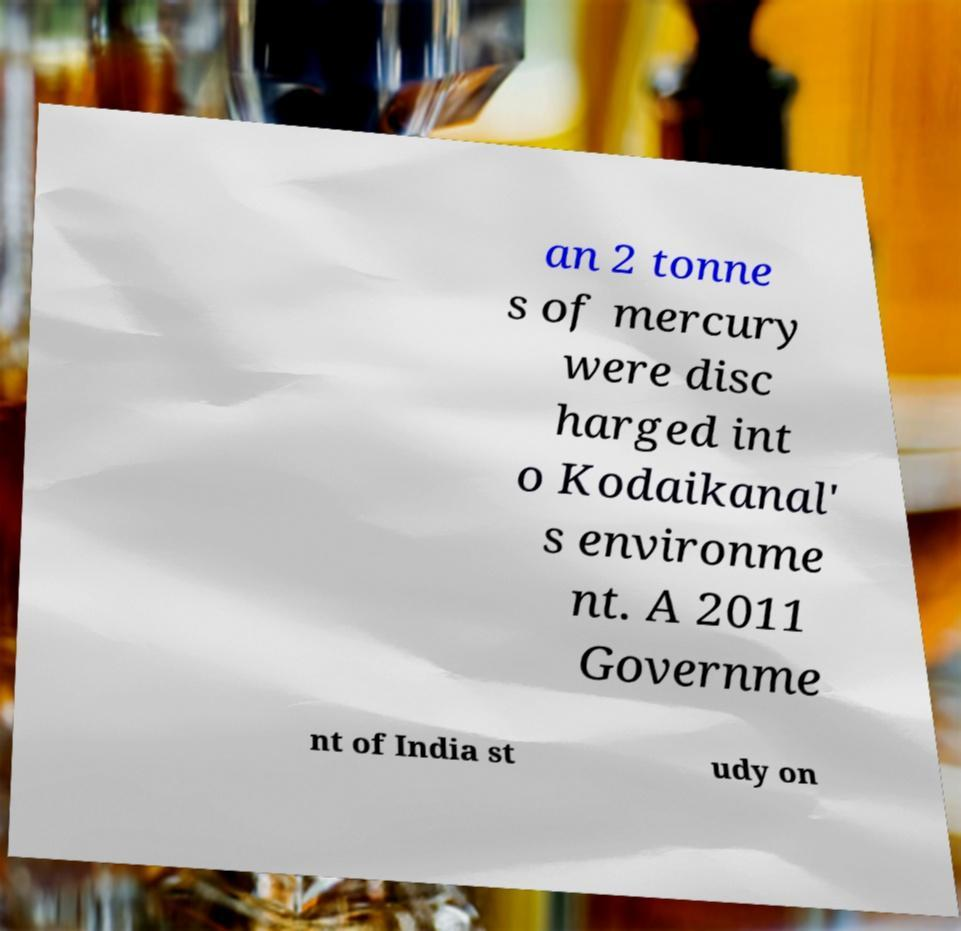Could you extract and type out the text from this image? an 2 tonne s of mercury were disc harged int o Kodaikanal' s environme nt. A 2011 Governme nt of India st udy on 